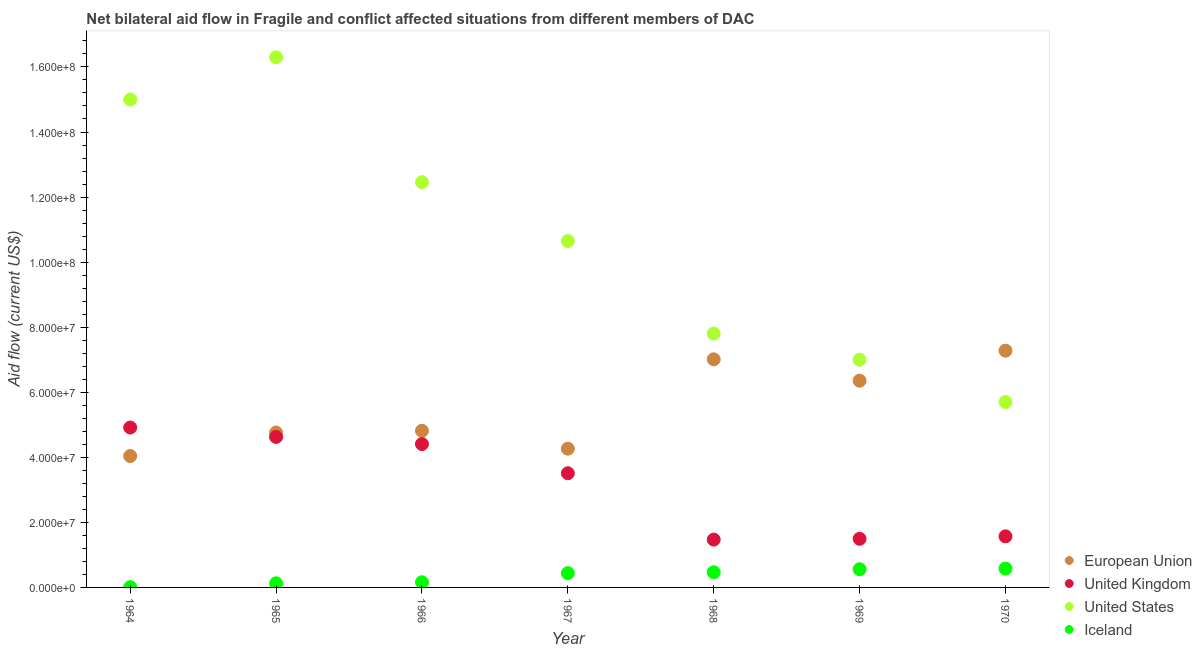How many different coloured dotlines are there?
Your answer should be compact. 4. What is the amount of aid given by us in 1969?
Ensure brevity in your answer.  7.00e+07. Across all years, what is the maximum amount of aid given by iceland?
Offer a very short reply. 5.80e+06. Across all years, what is the minimum amount of aid given by eu?
Offer a very short reply. 4.04e+07. In which year was the amount of aid given by eu maximum?
Ensure brevity in your answer.  1970. In which year was the amount of aid given by eu minimum?
Your response must be concise. 1964. What is the total amount of aid given by us in the graph?
Provide a succinct answer. 7.49e+08. What is the difference between the amount of aid given by uk in 1966 and that in 1967?
Your response must be concise. 8.98e+06. What is the difference between the amount of aid given by iceland in 1965 and the amount of aid given by us in 1964?
Offer a terse response. -1.49e+08. What is the average amount of aid given by us per year?
Give a very brief answer. 1.07e+08. In the year 1967, what is the difference between the amount of aid given by iceland and amount of aid given by us?
Ensure brevity in your answer.  -1.02e+08. In how many years, is the amount of aid given by us greater than 156000000 US$?
Your answer should be compact. 1. What is the ratio of the amount of aid given by eu in 1964 to that in 1967?
Your response must be concise. 0.95. What is the difference between the highest and the second highest amount of aid given by us?
Ensure brevity in your answer.  1.30e+07. What is the difference between the highest and the lowest amount of aid given by uk?
Your answer should be compact. 3.44e+07. In how many years, is the amount of aid given by iceland greater than the average amount of aid given by iceland taken over all years?
Make the answer very short. 4. Is it the case that in every year, the sum of the amount of aid given by iceland and amount of aid given by us is greater than the sum of amount of aid given by eu and amount of aid given by uk?
Your answer should be very brief. Yes. Does the amount of aid given by eu monotonically increase over the years?
Offer a terse response. No. Is the amount of aid given by eu strictly less than the amount of aid given by us over the years?
Give a very brief answer. No. How many years are there in the graph?
Ensure brevity in your answer.  7. What is the difference between two consecutive major ticks on the Y-axis?
Your answer should be compact. 2.00e+07. Does the graph contain any zero values?
Make the answer very short. No. Does the graph contain grids?
Give a very brief answer. No. How are the legend labels stacked?
Make the answer very short. Vertical. What is the title of the graph?
Ensure brevity in your answer.  Net bilateral aid flow in Fragile and conflict affected situations from different members of DAC. Does "Tracking ability" appear as one of the legend labels in the graph?
Keep it short and to the point. No. What is the label or title of the X-axis?
Ensure brevity in your answer.  Year. What is the label or title of the Y-axis?
Your answer should be compact. Aid flow (current US$). What is the Aid flow (current US$) of European Union in 1964?
Ensure brevity in your answer.  4.04e+07. What is the Aid flow (current US$) of United Kingdom in 1964?
Give a very brief answer. 4.92e+07. What is the Aid flow (current US$) in United States in 1964?
Your answer should be compact. 1.50e+08. What is the Aid flow (current US$) in Iceland in 1964?
Your response must be concise. 8.00e+04. What is the Aid flow (current US$) of European Union in 1965?
Provide a short and direct response. 4.76e+07. What is the Aid flow (current US$) in United Kingdom in 1965?
Offer a very short reply. 4.63e+07. What is the Aid flow (current US$) in United States in 1965?
Your answer should be compact. 1.63e+08. What is the Aid flow (current US$) of Iceland in 1965?
Provide a short and direct response. 1.25e+06. What is the Aid flow (current US$) of European Union in 1966?
Your answer should be compact. 4.82e+07. What is the Aid flow (current US$) of United Kingdom in 1966?
Your answer should be very brief. 4.41e+07. What is the Aid flow (current US$) in United States in 1966?
Provide a succinct answer. 1.25e+08. What is the Aid flow (current US$) in Iceland in 1966?
Your answer should be compact. 1.59e+06. What is the Aid flow (current US$) in European Union in 1967?
Your answer should be compact. 4.26e+07. What is the Aid flow (current US$) of United Kingdom in 1967?
Give a very brief answer. 3.51e+07. What is the Aid flow (current US$) in United States in 1967?
Provide a succinct answer. 1.06e+08. What is the Aid flow (current US$) of Iceland in 1967?
Provide a short and direct response. 4.39e+06. What is the Aid flow (current US$) in European Union in 1968?
Offer a terse response. 7.01e+07. What is the Aid flow (current US$) of United Kingdom in 1968?
Provide a succinct answer. 1.47e+07. What is the Aid flow (current US$) of United States in 1968?
Your answer should be very brief. 7.80e+07. What is the Aid flow (current US$) of Iceland in 1968?
Your answer should be very brief. 4.66e+06. What is the Aid flow (current US$) of European Union in 1969?
Provide a short and direct response. 6.36e+07. What is the Aid flow (current US$) in United Kingdom in 1969?
Give a very brief answer. 1.50e+07. What is the Aid flow (current US$) of United States in 1969?
Provide a succinct answer. 7.00e+07. What is the Aid flow (current US$) of Iceland in 1969?
Provide a short and direct response. 5.59e+06. What is the Aid flow (current US$) of European Union in 1970?
Ensure brevity in your answer.  7.28e+07. What is the Aid flow (current US$) in United Kingdom in 1970?
Your answer should be compact. 1.57e+07. What is the Aid flow (current US$) in United States in 1970?
Your answer should be compact. 5.70e+07. What is the Aid flow (current US$) in Iceland in 1970?
Your response must be concise. 5.80e+06. Across all years, what is the maximum Aid flow (current US$) of European Union?
Offer a terse response. 7.28e+07. Across all years, what is the maximum Aid flow (current US$) of United Kingdom?
Provide a short and direct response. 4.92e+07. Across all years, what is the maximum Aid flow (current US$) of United States?
Make the answer very short. 1.63e+08. Across all years, what is the maximum Aid flow (current US$) in Iceland?
Your answer should be very brief. 5.80e+06. Across all years, what is the minimum Aid flow (current US$) in European Union?
Keep it short and to the point. 4.04e+07. Across all years, what is the minimum Aid flow (current US$) in United Kingdom?
Make the answer very short. 1.47e+07. Across all years, what is the minimum Aid flow (current US$) of United States?
Offer a very short reply. 5.70e+07. What is the total Aid flow (current US$) in European Union in the graph?
Offer a terse response. 3.85e+08. What is the total Aid flow (current US$) of United Kingdom in the graph?
Make the answer very short. 2.20e+08. What is the total Aid flow (current US$) of United States in the graph?
Your response must be concise. 7.49e+08. What is the total Aid flow (current US$) in Iceland in the graph?
Provide a short and direct response. 2.34e+07. What is the difference between the Aid flow (current US$) in European Union in 1964 and that in 1965?
Provide a short and direct response. -7.22e+06. What is the difference between the Aid flow (current US$) in United Kingdom in 1964 and that in 1965?
Provide a succinct answer. 2.89e+06. What is the difference between the Aid flow (current US$) of United States in 1964 and that in 1965?
Give a very brief answer. -1.30e+07. What is the difference between the Aid flow (current US$) of Iceland in 1964 and that in 1965?
Provide a short and direct response. -1.17e+06. What is the difference between the Aid flow (current US$) of European Union in 1964 and that in 1966?
Your answer should be compact. -7.77e+06. What is the difference between the Aid flow (current US$) of United Kingdom in 1964 and that in 1966?
Keep it short and to the point. 5.07e+06. What is the difference between the Aid flow (current US$) of United States in 1964 and that in 1966?
Ensure brevity in your answer.  2.54e+07. What is the difference between the Aid flow (current US$) in Iceland in 1964 and that in 1966?
Offer a very short reply. -1.51e+06. What is the difference between the Aid flow (current US$) in European Union in 1964 and that in 1967?
Provide a succinct answer. -2.26e+06. What is the difference between the Aid flow (current US$) of United Kingdom in 1964 and that in 1967?
Offer a terse response. 1.40e+07. What is the difference between the Aid flow (current US$) of United States in 1964 and that in 1967?
Ensure brevity in your answer.  4.35e+07. What is the difference between the Aid flow (current US$) of Iceland in 1964 and that in 1967?
Provide a short and direct response. -4.31e+06. What is the difference between the Aid flow (current US$) in European Union in 1964 and that in 1968?
Provide a succinct answer. -2.97e+07. What is the difference between the Aid flow (current US$) in United Kingdom in 1964 and that in 1968?
Give a very brief answer. 3.44e+07. What is the difference between the Aid flow (current US$) in United States in 1964 and that in 1968?
Provide a short and direct response. 7.20e+07. What is the difference between the Aid flow (current US$) of Iceland in 1964 and that in 1968?
Provide a succinct answer. -4.58e+06. What is the difference between the Aid flow (current US$) of European Union in 1964 and that in 1969?
Give a very brief answer. -2.32e+07. What is the difference between the Aid flow (current US$) in United Kingdom in 1964 and that in 1969?
Provide a succinct answer. 3.42e+07. What is the difference between the Aid flow (current US$) of United States in 1964 and that in 1969?
Offer a very short reply. 8.00e+07. What is the difference between the Aid flow (current US$) of Iceland in 1964 and that in 1969?
Your answer should be very brief. -5.51e+06. What is the difference between the Aid flow (current US$) in European Union in 1964 and that in 1970?
Keep it short and to the point. -3.24e+07. What is the difference between the Aid flow (current US$) in United Kingdom in 1964 and that in 1970?
Ensure brevity in your answer.  3.34e+07. What is the difference between the Aid flow (current US$) in United States in 1964 and that in 1970?
Provide a short and direct response. 9.30e+07. What is the difference between the Aid flow (current US$) in Iceland in 1964 and that in 1970?
Offer a very short reply. -5.72e+06. What is the difference between the Aid flow (current US$) in European Union in 1965 and that in 1966?
Your response must be concise. -5.50e+05. What is the difference between the Aid flow (current US$) of United Kingdom in 1965 and that in 1966?
Offer a terse response. 2.18e+06. What is the difference between the Aid flow (current US$) in United States in 1965 and that in 1966?
Your response must be concise. 3.84e+07. What is the difference between the Aid flow (current US$) of European Union in 1965 and that in 1967?
Offer a very short reply. 4.96e+06. What is the difference between the Aid flow (current US$) in United Kingdom in 1965 and that in 1967?
Make the answer very short. 1.12e+07. What is the difference between the Aid flow (current US$) of United States in 1965 and that in 1967?
Provide a short and direct response. 5.65e+07. What is the difference between the Aid flow (current US$) of Iceland in 1965 and that in 1967?
Provide a succinct answer. -3.14e+06. What is the difference between the Aid flow (current US$) in European Union in 1965 and that in 1968?
Your response must be concise. -2.25e+07. What is the difference between the Aid flow (current US$) of United Kingdom in 1965 and that in 1968?
Give a very brief answer. 3.16e+07. What is the difference between the Aid flow (current US$) of United States in 1965 and that in 1968?
Ensure brevity in your answer.  8.49e+07. What is the difference between the Aid flow (current US$) of Iceland in 1965 and that in 1968?
Your answer should be very brief. -3.41e+06. What is the difference between the Aid flow (current US$) of European Union in 1965 and that in 1969?
Keep it short and to the point. -1.59e+07. What is the difference between the Aid flow (current US$) of United Kingdom in 1965 and that in 1969?
Your answer should be compact. 3.13e+07. What is the difference between the Aid flow (current US$) of United States in 1965 and that in 1969?
Provide a short and direct response. 9.30e+07. What is the difference between the Aid flow (current US$) of Iceland in 1965 and that in 1969?
Provide a short and direct response. -4.34e+06. What is the difference between the Aid flow (current US$) in European Union in 1965 and that in 1970?
Provide a short and direct response. -2.52e+07. What is the difference between the Aid flow (current US$) in United Kingdom in 1965 and that in 1970?
Your answer should be very brief. 3.06e+07. What is the difference between the Aid flow (current US$) of United States in 1965 and that in 1970?
Give a very brief answer. 1.06e+08. What is the difference between the Aid flow (current US$) of Iceland in 1965 and that in 1970?
Keep it short and to the point. -4.55e+06. What is the difference between the Aid flow (current US$) in European Union in 1966 and that in 1967?
Give a very brief answer. 5.51e+06. What is the difference between the Aid flow (current US$) in United Kingdom in 1966 and that in 1967?
Ensure brevity in your answer.  8.98e+06. What is the difference between the Aid flow (current US$) in United States in 1966 and that in 1967?
Your answer should be very brief. 1.81e+07. What is the difference between the Aid flow (current US$) of Iceland in 1966 and that in 1967?
Offer a terse response. -2.80e+06. What is the difference between the Aid flow (current US$) in European Union in 1966 and that in 1968?
Ensure brevity in your answer.  -2.20e+07. What is the difference between the Aid flow (current US$) in United Kingdom in 1966 and that in 1968?
Keep it short and to the point. 2.94e+07. What is the difference between the Aid flow (current US$) in United States in 1966 and that in 1968?
Keep it short and to the point. 4.65e+07. What is the difference between the Aid flow (current US$) of Iceland in 1966 and that in 1968?
Offer a very short reply. -3.07e+06. What is the difference between the Aid flow (current US$) of European Union in 1966 and that in 1969?
Offer a terse response. -1.54e+07. What is the difference between the Aid flow (current US$) of United Kingdom in 1966 and that in 1969?
Provide a short and direct response. 2.91e+07. What is the difference between the Aid flow (current US$) in United States in 1966 and that in 1969?
Make the answer very short. 5.46e+07. What is the difference between the Aid flow (current US$) in Iceland in 1966 and that in 1969?
Provide a succinct answer. -4.00e+06. What is the difference between the Aid flow (current US$) of European Union in 1966 and that in 1970?
Provide a succinct answer. -2.46e+07. What is the difference between the Aid flow (current US$) of United Kingdom in 1966 and that in 1970?
Keep it short and to the point. 2.84e+07. What is the difference between the Aid flow (current US$) of United States in 1966 and that in 1970?
Provide a short and direct response. 6.76e+07. What is the difference between the Aid flow (current US$) in Iceland in 1966 and that in 1970?
Your answer should be compact. -4.21e+06. What is the difference between the Aid flow (current US$) in European Union in 1967 and that in 1968?
Your response must be concise. -2.75e+07. What is the difference between the Aid flow (current US$) in United Kingdom in 1967 and that in 1968?
Your answer should be very brief. 2.04e+07. What is the difference between the Aid flow (current US$) of United States in 1967 and that in 1968?
Offer a terse response. 2.84e+07. What is the difference between the Aid flow (current US$) in European Union in 1967 and that in 1969?
Your answer should be very brief. -2.09e+07. What is the difference between the Aid flow (current US$) in United Kingdom in 1967 and that in 1969?
Offer a very short reply. 2.02e+07. What is the difference between the Aid flow (current US$) of United States in 1967 and that in 1969?
Ensure brevity in your answer.  3.65e+07. What is the difference between the Aid flow (current US$) of Iceland in 1967 and that in 1969?
Make the answer very short. -1.20e+06. What is the difference between the Aid flow (current US$) in European Union in 1967 and that in 1970?
Make the answer very short. -3.01e+07. What is the difference between the Aid flow (current US$) in United Kingdom in 1967 and that in 1970?
Give a very brief answer. 1.94e+07. What is the difference between the Aid flow (current US$) of United States in 1967 and that in 1970?
Provide a succinct answer. 4.95e+07. What is the difference between the Aid flow (current US$) in Iceland in 1967 and that in 1970?
Your answer should be compact. -1.41e+06. What is the difference between the Aid flow (current US$) of European Union in 1968 and that in 1969?
Your answer should be compact. 6.57e+06. What is the difference between the Aid flow (current US$) in United States in 1968 and that in 1969?
Make the answer very short. 8.04e+06. What is the difference between the Aid flow (current US$) in Iceland in 1968 and that in 1969?
Offer a terse response. -9.30e+05. What is the difference between the Aid flow (current US$) in European Union in 1968 and that in 1970?
Provide a short and direct response. -2.66e+06. What is the difference between the Aid flow (current US$) of United Kingdom in 1968 and that in 1970?
Offer a very short reply. -1.01e+06. What is the difference between the Aid flow (current US$) of United States in 1968 and that in 1970?
Your answer should be very brief. 2.10e+07. What is the difference between the Aid flow (current US$) of Iceland in 1968 and that in 1970?
Ensure brevity in your answer.  -1.14e+06. What is the difference between the Aid flow (current US$) of European Union in 1969 and that in 1970?
Ensure brevity in your answer.  -9.23e+06. What is the difference between the Aid flow (current US$) of United Kingdom in 1969 and that in 1970?
Make the answer very short. -7.60e+05. What is the difference between the Aid flow (current US$) of United States in 1969 and that in 1970?
Your answer should be very brief. 1.30e+07. What is the difference between the Aid flow (current US$) in European Union in 1964 and the Aid flow (current US$) in United Kingdom in 1965?
Your response must be concise. -5.87e+06. What is the difference between the Aid flow (current US$) of European Union in 1964 and the Aid flow (current US$) of United States in 1965?
Your response must be concise. -1.23e+08. What is the difference between the Aid flow (current US$) in European Union in 1964 and the Aid flow (current US$) in Iceland in 1965?
Keep it short and to the point. 3.91e+07. What is the difference between the Aid flow (current US$) in United Kingdom in 1964 and the Aid flow (current US$) in United States in 1965?
Offer a very short reply. -1.14e+08. What is the difference between the Aid flow (current US$) of United Kingdom in 1964 and the Aid flow (current US$) of Iceland in 1965?
Make the answer very short. 4.79e+07. What is the difference between the Aid flow (current US$) of United States in 1964 and the Aid flow (current US$) of Iceland in 1965?
Your answer should be very brief. 1.49e+08. What is the difference between the Aid flow (current US$) in European Union in 1964 and the Aid flow (current US$) in United Kingdom in 1966?
Give a very brief answer. -3.69e+06. What is the difference between the Aid flow (current US$) in European Union in 1964 and the Aid flow (current US$) in United States in 1966?
Keep it short and to the point. -8.42e+07. What is the difference between the Aid flow (current US$) in European Union in 1964 and the Aid flow (current US$) in Iceland in 1966?
Keep it short and to the point. 3.88e+07. What is the difference between the Aid flow (current US$) in United Kingdom in 1964 and the Aid flow (current US$) in United States in 1966?
Ensure brevity in your answer.  -7.54e+07. What is the difference between the Aid flow (current US$) in United Kingdom in 1964 and the Aid flow (current US$) in Iceland in 1966?
Offer a terse response. 4.76e+07. What is the difference between the Aid flow (current US$) of United States in 1964 and the Aid flow (current US$) of Iceland in 1966?
Provide a short and direct response. 1.48e+08. What is the difference between the Aid flow (current US$) in European Union in 1964 and the Aid flow (current US$) in United Kingdom in 1967?
Provide a succinct answer. 5.29e+06. What is the difference between the Aid flow (current US$) of European Union in 1964 and the Aid flow (current US$) of United States in 1967?
Your answer should be very brief. -6.61e+07. What is the difference between the Aid flow (current US$) of European Union in 1964 and the Aid flow (current US$) of Iceland in 1967?
Keep it short and to the point. 3.60e+07. What is the difference between the Aid flow (current US$) in United Kingdom in 1964 and the Aid flow (current US$) in United States in 1967?
Give a very brief answer. -5.73e+07. What is the difference between the Aid flow (current US$) in United Kingdom in 1964 and the Aid flow (current US$) in Iceland in 1967?
Provide a succinct answer. 4.48e+07. What is the difference between the Aid flow (current US$) of United States in 1964 and the Aid flow (current US$) of Iceland in 1967?
Ensure brevity in your answer.  1.46e+08. What is the difference between the Aid flow (current US$) in European Union in 1964 and the Aid flow (current US$) in United Kingdom in 1968?
Provide a short and direct response. 2.57e+07. What is the difference between the Aid flow (current US$) of European Union in 1964 and the Aid flow (current US$) of United States in 1968?
Keep it short and to the point. -3.76e+07. What is the difference between the Aid flow (current US$) of European Union in 1964 and the Aid flow (current US$) of Iceland in 1968?
Offer a very short reply. 3.57e+07. What is the difference between the Aid flow (current US$) in United Kingdom in 1964 and the Aid flow (current US$) in United States in 1968?
Your response must be concise. -2.89e+07. What is the difference between the Aid flow (current US$) of United Kingdom in 1964 and the Aid flow (current US$) of Iceland in 1968?
Provide a short and direct response. 4.45e+07. What is the difference between the Aid flow (current US$) in United States in 1964 and the Aid flow (current US$) in Iceland in 1968?
Keep it short and to the point. 1.45e+08. What is the difference between the Aid flow (current US$) in European Union in 1964 and the Aid flow (current US$) in United Kingdom in 1969?
Your response must be concise. 2.54e+07. What is the difference between the Aid flow (current US$) of European Union in 1964 and the Aid flow (current US$) of United States in 1969?
Your response must be concise. -2.96e+07. What is the difference between the Aid flow (current US$) of European Union in 1964 and the Aid flow (current US$) of Iceland in 1969?
Your answer should be very brief. 3.48e+07. What is the difference between the Aid flow (current US$) in United Kingdom in 1964 and the Aid flow (current US$) in United States in 1969?
Offer a terse response. -2.08e+07. What is the difference between the Aid flow (current US$) of United Kingdom in 1964 and the Aid flow (current US$) of Iceland in 1969?
Your response must be concise. 4.36e+07. What is the difference between the Aid flow (current US$) in United States in 1964 and the Aid flow (current US$) in Iceland in 1969?
Provide a short and direct response. 1.44e+08. What is the difference between the Aid flow (current US$) in European Union in 1964 and the Aid flow (current US$) in United Kingdom in 1970?
Make the answer very short. 2.47e+07. What is the difference between the Aid flow (current US$) in European Union in 1964 and the Aid flow (current US$) in United States in 1970?
Your answer should be very brief. -1.66e+07. What is the difference between the Aid flow (current US$) in European Union in 1964 and the Aid flow (current US$) in Iceland in 1970?
Your answer should be very brief. 3.46e+07. What is the difference between the Aid flow (current US$) of United Kingdom in 1964 and the Aid flow (current US$) of United States in 1970?
Provide a short and direct response. -7.85e+06. What is the difference between the Aid flow (current US$) in United Kingdom in 1964 and the Aid flow (current US$) in Iceland in 1970?
Ensure brevity in your answer.  4.34e+07. What is the difference between the Aid flow (current US$) in United States in 1964 and the Aid flow (current US$) in Iceland in 1970?
Your answer should be compact. 1.44e+08. What is the difference between the Aid flow (current US$) of European Union in 1965 and the Aid flow (current US$) of United Kingdom in 1966?
Your response must be concise. 3.53e+06. What is the difference between the Aid flow (current US$) of European Union in 1965 and the Aid flow (current US$) of United States in 1966?
Offer a very short reply. -7.70e+07. What is the difference between the Aid flow (current US$) in European Union in 1965 and the Aid flow (current US$) in Iceland in 1966?
Offer a terse response. 4.60e+07. What is the difference between the Aid flow (current US$) in United Kingdom in 1965 and the Aid flow (current US$) in United States in 1966?
Offer a very short reply. -7.83e+07. What is the difference between the Aid flow (current US$) in United Kingdom in 1965 and the Aid flow (current US$) in Iceland in 1966?
Provide a succinct answer. 4.47e+07. What is the difference between the Aid flow (current US$) of United States in 1965 and the Aid flow (current US$) of Iceland in 1966?
Keep it short and to the point. 1.61e+08. What is the difference between the Aid flow (current US$) in European Union in 1965 and the Aid flow (current US$) in United Kingdom in 1967?
Give a very brief answer. 1.25e+07. What is the difference between the Aid flow (current US$) of European Union in 1965 and the Aid flow (current US$) of United States in 1967?
Provide a succinct answer. -5.89e+07. What is the difference between the Aid flow (current US$) of European Union in 1965 and the Aid flow (current US$) of Iceland in 1967?
Provide a succinct answer. 4.32e+07. What is the difference between the Aid flow (current US$) in United Kingdom in 1965 and the Aid flow (current US$) in United States in 1967?
Your answer should be very brief. -6.02e+07. What is the difference between the Aid flow (current US$) of United Kingdom in 1965 and the Aid flow (current US$) of Iceland in 1967?
Ensure brevity in your answer.  4.19e+07. What is the difference between the Aid flow (current US$) in United States in 1965 and the Aid flow (current US$) in Iceland in 1967?
Your answer should be very brief. 1.59e+08. What is the difference between the Aid flow (current US$) in European Union in 1965 and the Aid flow (current US$) in United Kingdom in 1968?
Provide a succinct answer. 3.29e+07. What is the difference between the Aid flow (current US$) in European Union in 1965 and the Aid flow (current US$) in United States in 1968?
Offer a terse response. -3.04e+07. What is the difference between the Aid flow (current US$) in European Union in 1965 and the Aid flow (current US$) in Iceland in 1968?
Ensure brevity in your answer.  4.30e+07. What is the difference between the Aid flow (current US$) in United Kingdom in 1965 and the Aid flow (current US$) in United States in 1968?
Make the answer very short. -3.18e+07. What is the difference between the Aid flow (current US$) of United Kingdom in 1965 and the Aid flow (current US$) of Iceland in 1968?
Your answer should be compact. 4.16e+07. What is the difference between the Aid flow (current US$) of United States in 1965 and the Aid flow (current US$) of Iceland in 1968?
Give a very brief answer. 1.58e+08. What is the difference between the Aid flow (current US$) of European Union in 1965 and the Aid flow (current US$) of United Kingdom in 1969?
Your answer should be compact. 3.27e+07. What is the difference between the Aid flow (current US$) of European Union in 1965 and the Aid flow (current US$) of United States in 1969?
Your answer should be compact. -2.24e+07. What is the difference between the Aid flow (current US$) in European Union in 1965 and the Aid flow (current US$) in Iceland in 1969?
Your answer should be compact. 4.20e+07. What is the difference between the Aid flow (current US$) in United Kingdom in 1965 and the Aid flow (current US$) in United States in 1969?
Keep it short and to the point. -2.37e+07. What is the difference between the Aid flow (current US$) in United Kingdom in 1965 and the Aid flow (current US$) in Iceland in 1969?
Your answer should be compact. 4.07e+07. What is the difference between the Aid flow (current US$) in United States in 1965 and the Aid flow (current US$) in Iceland in 1969?
Your answer should be compact. 1.57e+08. What is the difference between the Aid flow (current US$) of European Union in 1965 and the Aid flow (current US$) of United Kingdom in 1970?
Make the answer very short. 3.19e+07. What is the difference between the Aid flow (current US$) in European Union in 1965 and the Aid flow (current US$) in United States in 1970?
Keep it short and to the point. -9.39e+06. What is the difference between the Aid flow (current US$) of European Union in 1965 and the Aid flow (current US$) of Iceland in 1970?
Offer a very short reply. 4.18e+07. What is the difference between the Aid flow (current US$) in United Kingdom in 1965 and the Aid flow (current US$) in United States in 1970?
Your response must be concise. -1.07e+07. What is the difference between the Aid flow (current US$) in United Kingdom in 1965 and the Aid flow (current US$) in Iceland in 1970?
Make the answer very short. 4.05e+07. What is the difference between the Aid flow (current US$) in United States in 1965 and the Aid flow (current US$) in Iceland in 1970?
Keep it short and to the point. 1.57e+08. What is the difference between the Aid flow (current US$) in European Union in 1966 and the Aid flow (current US$) in United Kingdom in 1967?
Provide a short and direct response. 1.31e+07. What is the difference between the Aid flow (current US$) in European Union in 1966 and the Aid flow (current US$) in United States in 1967?
Offer a very short reply. -5.83e+07. What is the difference between the Aid flow (current US$) of European Union in 1966 and the Aid flow (current US$) of Iceland in 1967?
Your answer should be compact. 4.38e+07. What is the difference between the Aid flow (current US$) of United Kingdom in 1966 and the Aid flow (current US$) of United States in 1967?
Offer a very short reply. -6.24e+07. What is the difference between the Aid flow (current US$) of United Kingdom in 1966 and the Aid flow (current US$) of Iceland in 1967?
Ensure brevity in your answer.  3.97e+07. What is the difference between the Aid flow (current US$) of United States in 1966 and the Aid flow (current US$) of Iceland in 1967?
Your response must be concise. 1.20e+08. What is the difference between the Aid flow (current US$) of European Union in 1966 and the Aid flow (current US$) of United Kingdom in 1968?
Your response must be concise. 3.35e+07. What is the difference between the Aid flow (current US$) in European Union in 1966 and the Aid flow (current US$) in United States in 1968?
Your answer should be compact. -2.99e+07. What is the difference between the Aid flow (current US$) of European Union in 1966 and the Aid flow (current US$) of Iceland in 1968?
Provide a short and direct response. 4.35e+07. What is the difference between the Aid flow (current US$) of United Kingdom in 1966 and the Aid flow (current US$) of United States in 1968?
Provide a succinct answer. -3.40e+07. What is the difference between the Aid flow (current US$) in United Kingdom in 1966 and the Aid flow (current US$) in Iceland in 1968?
Your answer should be compact. 3.94e+07. What is the difference between the Aid flow (current US$) of United States in 1966 and the Aid flow (current US$) of Iceland in 1968?
Provide a short and direct response. 1.20e+08. What is the difference between the Aid flow (current US$) of European Union in 1966 and the Aid flow (current US$) of United Kingdom in 1969?
Offer a terse response. 3.32e+07. What is the difference between the Aid flow (current US$) of European Union in 1966 and the Aid flow (current US$) of United States in 1969?
Provide a succinct answer. -2.18e+07. What is the difference between the Aid flow (current US$) in European Union in 1966 and the Aid flow (current US$) in Iceland in 1969?
Your response must be concise. 4.26e+07. What is the difference between the Aid flow (current US$) of United Kingdom in 1966 and the Aid flow (current US$) of United States in 1969?
Your answer should be compact. -2.59e+07. What is the difference between the Aid flow (current US$) in United Kingdom in 1966 and the Aid flow (current US$) in Iceland in 1969?
Your answer should be very brief. 3.85e+07. What is the difference between the Aid flow (current US$) of United States in 1966 and the Aid flow (current US$) of Iceland in 1969?
Give a very brief answer. 1.19e+08. What is the difference between the Aid flow (current US$) of European Union in 1966 and the Aid flow (current US$) of United Kingdom in 1970?
Give a very brief answer. 3.24e+07. What is the difference between the Aid flow (current US$) of European Union in 1966 and the Aid flow (current US$) of United States in 1970?
Provide a succinct answer. -8.84e+06. What is the difference between the Aid flow (current US$) of European Union in 1966 and the Aid flow (current US$) of Iceland in 1970?
Your response must be concise. 4.24e+07. What is the difference between the Aid flow (current US$) of United Kingdom in 1966 and the Aid flow (current US$) of United States in 1970?
Your answer should be very brief. -1.29e+07. What is the difference between the Aid flow (current US$) of United Kingdom in 1966 and the Aid flow (current US$) of Iceland in 1970?
Make the answer very short. 3.83e+07. What is the difference between the Aid flow (current US$) in United States in 1966 and the Aid flow (current US$) in Iceland in 1970?
Provide a succinct answer. 1.19e+08. What is the difference between the Aid flow (current US$) in European Union in 1967 and the Aid flow (current US$) in United Kingdom in 1968?
Give a very brief answer. 2.80e+07. What is the difference between the Aid flow (current US$) of European Union in 1967 and the Aid flow (current US$) of United States in 1968?
Your response must be concise. -3.54e+07. What is the difference between the Aid flow (current US$) in European Union in 1967 and the Aid flow (current US$) in Iceland in 1968?
Your answer should be very brief. 3.80e+07. What is the difference between the Aid flow (current US$) of United Kingdom in 1967 and the Aid flow (current US$) of United States in 1968?
Offer a very short reply. -4.29e+07. What is the difference between the Aid flow (current US$) in United Kingdom in 1967 and the Aid flow (current US$) in Iceland in 1968?
Offer a very short reply. 3.04e+07. What is the difference between the Aid flow (current US$) in United States in 1967 and the Aid flow (current US$) in Iceland in 1968?
Your response must be concise. 1.02e+08. What is the difference between the Aid flow (current US$) of European Union in 1967 and the Aid flow (current US$) of United Kingdom in 1969?
Your answer should be compact. 2.77e+07. What is the difference between the Aid flow (current US$) in European Union in 1967 and the Aid flow (current US$) in United States in 1969?
Offer a very short reply. -2.74e+07. What is the difference between the Aid flow (current US$) of European Union in 1967 and the Aid flow (current US$) of Iceland in 1969?
Ensure brevity in your answer.  3.71e+07. What is the difference between the Aid flow (current US$) of United Kingdom in 1967 and the Aid flow (current US$) of United States in 1969?
Offer a terse response. -3.49e+07. What is the difference between the Aid flow (current US$) of United Kingdom in 1967 and the Aid flow (current US$) of Iceland in 1969?
Make the answer very short. 2.95e+07. What is the difference between the Aid flow (current US$) of United States in 1967 and the Aid flow (current US$) of Iceland in 1969?
Your answer should be very brief. 1.01e+08. What is the difference between the Aid flow (current US$) of European Union in 1967 and the Aid flow (current US$) of United Kingdom in 1970?
Offer a very short reply. 2.69e+07. What is the difference between the Aid flow (current US$) in European Union in 1967 and the Aid flow (current US$) in United States in 1970?
Your answer should be very brief. -1.44e+07. What is the difference between the Aid flow (current US$) in European Union in 1967 and the Aid flow (current US$) in Iceland in 1970?
Ensure brevity in your answer.  3.68e+07. What is the difference between the Aid flow (current US$) of United Kingdom in 1967 and the Aid flow (current US$) of United States in 1970?
Your answer should be very brief. -2.19e+07. What is the difference between the Aid flow (current US$) of United Kingdom in 1967 and the Aid flow (current US$) of Iceland in 1970?
Provide a short and direct response. 2.93e+07. What is the difference between the Aid flow (current US$) in United States in 1967 and the Aid flow (current US$) in Iceland in 1970?
Give a very brief answer. 1.01e+08. What is the difference between the Aid flow (current US$) of European Union in 1968 and the Aid flow (current US$) of United Kingdom in 1969?
Offer a terse response. 5.52e+07. What is the difference between the Aid flow (current US$) in European Union in 1968 and the Aid flow (current US$) in United States in 1969?
Your answer should be compact. 1.20e+05. What is the difference between the Aid flow (current US$) of European Union in 1968 and the Aid flow (current US$) of Iceland in 1969?
Your answer should be compact. 6.45e+07. What is the difference between the Aid flow (current US$) in United Kingdom in 1968 and the Aid flow (current US$) in United States in 1969?
Give a very brief answer. -5.53e+07. What is the difference between the Aid flow (current US$) in United Kingdom in 1968 and the Aid flow (current US$) in Iceland in 1969?
Offer a terse response. 9.11e+06. What is the difference between the Aid flow (current US$) in United States in 1968 and the Aid flow (current US$) in Iceland in 1969?
Your answer should be very brief. 7.24e+07. What is the difference between the Aid flow (current US$) in European Union in 1968 and the Aid flow (current US$) in United Kingdom in 1970?
Your answer should be very brief. 5.44e+07. What is the difference between the Aid flow (current US$) in European Union in 1968 and the Aid flow (current US$) in United States in 1970?
Offer a terse response. 1.31e+07. What is the difference between the Aid flow (current US$) in European Union in 1968 and the Aid flow (current US$) in Iceland in 1970?
Give a very brief answer. 6.43e+07. What is the difference between the Aid flow (current US$) in United Kingdom in 1968 and the Aid flow (current US$) in United States in 1970?
Make the answer very short. -4.23e+07. What is the difference between the Aid flow (current US$) of United Kingdom in 1968 and the Aid flow (current US$) of Iceland in 1970?
Make the answer very short. 8.90e+06. What is the difference between the Aid flow (current US$) of United States in 1968 and the Aid flow (current US$) of Iceland in 1970?
Provide a short and direct response. 7.22e+07. What is the difference between the Aid flow (current US$) in European Union in 1969 and the Aid flow (current US$) in United Kingdom in 1970?
Make the answer very short. 4.78e+07. What is the difference between the Aid flow (current US$) of European Union in 1969 and the Aid flow (current US$) of United States in 1970?
Make the answer very short. 6.55e+06. What is the difference between the Aid flow (current US$) of European Union in 1969 and the Aid flow (current US$) of Iceland in 1970?
Offer a very short reply. 5.78e+07. What is the difference between the Aid flow (current US$) of United Kingdom in 1969 and the Aid flow (current US$) of United States in 1970?
Provide a short and direct response. -4.20e+07. What is the difference between the Aid flow (current US$) of United Kingdom in 1969 and the Aid flow (current US$) of Iceland in 1970?
Your answer should be compact. 9.15e+06. What is the difference between the Aid flow (current US$) in United States in 1969 and the Aid flow (current US$) in Iceland in 1970?
Provide a short and direct response. 6.42e+07. What is the average Aid flow (current US$) in European Union per year?
Keep it short and to the point. 5.50e+07. What is the average Aid flow (current US$) in United Kingdom per year?
Your answer should be very brief. 3.14e+07. What is the average Aid flow (current US$) in United States per year?
Keep it short and to the point. 1.07e+08. What is the average Aid flow (current US$) in Iceland per year?
Provide a succinct answer. 3.34e+06. In the year 1964, what is the difference between the Aid flow (current US$) of European Union and Aid flow (current US$) of United Kingdom?
Ensure brevity in your answer.  -8.76e+06. In the year 1964, what is the difference between the Aid flow (current US$) of European Union and Aid flow (current US$) of United States?
Ensure brevity in your answer.  -1.10e+08. In the year 1964, what is the difference between the Aid flow (current US$) of European Union and Aid flow (current US$) of Iceland?
Your response must be concise. 4.03e+07. In the year 1964, what is the difference between the Aid flow (current US$) in United Kingdom and Aid flow (current US$) in United States?
Ensure brevity in your answer.  -1.01e+08. In the year 1964, what is the difference between the Aid flow (current US$) of United Kingdom and Aid flow (current US$) of Iceland?
Make the answer very short. 4.91e+07. In the year 1964, what is the difference between the Aid flow (current US$) in United States and Aid flow (current US$) in Iceland?
Your answer should be compact. 1.50e+08. In the year 1965, what is the difference between the Aid flow (current US$) in European Union and Aid flow (current US$) in United Kingdom?
Provide a short and direct response. 1.35e+06. In the year 1965, what is the difference between the Aid flow (current US$) of European Union and Aid flow (current US$) of United States?
Offer a very short reply. -1.15e+08. In the year 1965, what is the difference between the Aid flow (current US$) of European Union and Aid flow (current US$) of Iceland?
Offer a terse response. 4.64e+07. In the year 1965, what is the difference between the Aid flow (current US$) of United Kingdom and Aid flow (current US$) of United States?
Your response must be concise. -1.17e+08. In the year 1965, what is the difference between the Aid flow (current US$) of United Kingdom and Aid flow (current US$) of Iceland?
Your answer should be compact. 4.50e+07. In the year 1965, what is the difference between the Aid flow (current US$) of United States and Aid flow (current US$) of Iceland?
Your response must be concise. 1.62e+08. In the year 1966, what is the difference between the Aid flow (current US$) in European Union and Aid flow (current US$) in United Kingdom?
Provide a short and direct response. 4.08e+06. In the year 1966, what is the difference between the Aid flow (current US$) of European Union and Aid flow (current US$) of United States?
Your answer should be very brief. -7.64e+07. In the year 1966, what is the difference between the Aid flow (current US$) of European Union and Aid flow (current US$) of Iceland?
Ensure brevity in your answer.  4.66e+07. In the year 1966, what is the difference between the Aid flow (current US$) of United Kingdom and Aid flow (current US$) of United States?
Offer a terse response. -8.05e+07. In the year 1966, what is the difference between the Aid flow (current US$) in United Kingdom and Aid flow (current US$) in Iceland?
Make the answer very short. 4.25e+07. In the year 1966, what is the difference between the Aid flow (current US$) in United States and Aid flow (current US$) in Iceland?
Offer a terse response. 1.23e+08. In the year 1967, what is the difference between the Aid flow (current US$) in European Union and Aid flow (current US$) in United Kingdom?
Your answer should be very brief. 7.55e+06. In the year 1967, what is the difference between the Aid flow (current US$) in European Union and Aid flow (current US$) in United States?
Give a very brief answer. -6.38e+07. In the year 1967, what is the difference between the Aid flow (current US$) of European Union and Aid flow (current US$) of Iceland?
Your answer should be compact. 3.83e+07. In the year 1967, what is the difference between the Aid flow (current US$) of United Kingdom and Aid flow (current US$) of United States?
Your answer should be compact. -7.14e+07. In the year 1967, what is the difference between the Aid flow (current US$) of United Kingdom and Aid flow (current US$) of Iceland?
Your answer should be compact. 3.07e+07. In the year 1967, what is the difference between the Aid flow (current US$) of United States and Aid flow (current US$) of Iceland?
Your response must be concise. 1.02e+08. In the year 1968, what is the difference between the Aid flow (current US$) in European Union and Aid flow (current US$) in United Kingdom?
Ensure brevity in your answer.  5.54e+07. In the year 1968, what is the difference between the Aid flow (current US$) in European Union and Aid flow (current US$) in United States?
Ensure brevity in your answer.  -7.92e+06. In the year 1968, what is the difference between the Aid flow (current US$) of European Union and Aid flow (current US$) of Iceland?
Provide a short and direct response. 6.55e+07. In the year 1968, what is the difference between the Aid flow (current US$) in United Kingdom and Aid flow (current US$) in United States?
Offer a very short reply. -6.33e+07. In the year 1968, what is the difference between the Aid flow (current US$) of United Kingdom and Aid flow (current US$) of Iceland?
Keep it short and to the point. 1.00e+07. In the year 1968, what is the difference between the Aid flow (current US$) of United States and Aid flow (current US$) of Iceland?
Provide a short and direct response. 7.34e+07. In the year 1969, what is the difference between the Aid flow (current US$) in European Union and Aid flow (current US$) in United Kingdom?
Ensure brevity in your answer.  4.86e+07. In the year 1969, what is the difference between the Aid flow (current US$) of European Union and Aid flow (current US$) of United States?
Keep it short and to the point. -6.45e+06. In the year 1969, what is the difference between the Aid flow (current US$) of European Union and Aid flow (current US$) of Iceland?
Your answer should be very brief. 5.80e+07. In the year 1969, what is the difference between the Aid flow (current US$) in United Kingdom and Aid flow (current US$) in United States?
Ensure brevity in your answer.  -5.50e+07. In the year 1969, what is the difference between the Aid flow (current US$) in United Kingdom and Aid flow (current US$) in Iceland?
Keep it short and to the point. 9.36e+06. In the year 1969, what is the difference between the Aid flow (current US$) in United States and Aid flow (current US$) in Iceland?
Your answer should be compact. 6.44e+07. In the year 1970, what is the difference between the Aid flow (current US$) of European Union and Aid flow (current US$) of United Kingdom?
Your answer should be very brief. 5.71e+07. In the year 1970, what is the difference between the Aid flow (current US$) of European Union and Aid flow (current US$) of United States?
Offer a terse response. 1.58e+07. In the year 1970, what is the difference between the Aid flow (current US$) of European Union and Aid flow (current US$) of Iceland?
Your answer should be compact. 6.70e+07. In the year 1970, what is the difference between the Aid flow (current US$) of United Kingdom and Aid flow (current US$) of United States?
Ensure brevity in your answer.  -4.13e+07. In the year 1970, what is the difference between the Aid flow (current US$) in United Kingdom and Aid flow (current US$) in Iceland?
Provide a succinct answer. 9.91e+06. In the year 1970, what is the difference between the Aid flow (current US$) in United States and Aid flow (current US$) in Iceland?
Your response must be concise. 5.12e+07. What is the ratio of the Aid flow (current US$) of European Union in 1964 to that in 1965?
Provide a short and direct response. 0.85. What is the ratio of the Aid flow (current US$) in United States in 1964 to that in 1965?
Offer a very short reply. 0.92. What is the ratio of the Aid flow (current US$) of Iceland in 1964 to that in 1965?
Your response must be concise. 0.06. What is the ratio of the Aid flow (current US$) in European Union in 1964 to that in 1966?
Offer a terse response. 0.84. What is the ratio of the Aid flow (current US$) in United Kingdom in 1964 to that in 1966?
Keep it short and to the point. 1.11. What is the ratio of the Aid flow (current US$) in United States in 1964 to that in 1966?
Ensure brevity in your answer.  1.2. What is the ratio of the Aid flow (current US$) in Iceland in 1964 to that in 1966?
Make the answer very short. 0.05. What is the ratio of the Aid flow (current US$) in European Union in 1964 to that in 1967?
Ensure brevity in your answer.  0.95. What is the ratio of the Aid flow (current US$) of United Kingdom in 1964 to that in 1967?
Offer a terse response. 1.4. What is the ratio of the Aid flow (current US$) of United States in 1964 to that in 1967?
Offer a very short reply. 1.41. What is the ratio of the Aid flow (current US$) of Iceland in 1964 to that in 1967?
Ensure brevity in your answer.  0.02. What is the ratio of the Aid flow (current US$) in European Union in 1964 to that in 1968?
Your response must be concise. 0.58. What is the ratio of the Aid flow (current US$) in United Kingdom in 1964 to that in 1968?
Offer a very short reply. 3.34. What is the ratio of the Aid flow (current US$) of United States in 1964 to that in 1968?
Offer a very short reply. 1.92. What is the ratio of the Aid flow (current US$) of Iceland in 1964 to that in 1968?
Give a very brief answer. 0.02. What is the ratio of the Aid flow (current US$) in European Union in 1964 to that in 1969?
Ensure brevity in your answer.  0.64. What is the ratio of the Aid flow (current US$) in United Kingdom in 1964 to that in 1969?
Your answer should be very brief. 3.29. What is the ratio of the Aid flow (current US$) in United States in 1964 to that in 1969?
Your response must be concise. 2.14. What is the ratio of the Aid flow (current US$) of Iceland in 1964 to that in 1969?
Make the answer very short. 0.01. What is the ratio of the Aid flow (current US$) in European Union in 1964 to that in 1970?
Give a very brief answer. 0.56. What is the ratio of the Aid flow (current US$) in United Kingdom in 1964 to that in 1970?
Provide a succinct answer. 3.13. What is the ratio of the Aid flow (current US$) of United States in 1964 to that in 1970?
Give a very brief answer. 2.63. What is the ratio of the Aid flow (current US$) of Iceland in 1964 to that in 1970?
Keep it short and to the point. 0.01. What is the ratio of the Aid flow (current US$) of European Union in 1965 to that in 1966?
Provide a succinct answer. 0.99. What is the ratio of the Aid flow (current US$) of United Kingdom in 1965 to that in 1966?
Provide a short and direct response. 1.05. What is the ratio of the Aid flow (current US$) of United States in 1965 to that in 1966?
Provide a succinct answer. 1.31. What is the ratio of the Aid flow (current US$) of Iceland in 1965 to that in 1966?
Your response must be concise. 0.79. What is the ratio of the Aid flow (current US$) of European Union in 1965 to that in 1967?
Make the answer very short. 1.12. What is the ratio of the Aid flow (current US$) in United Kingdom in 1965 to that in 1967?
Ensure brevity in your answer.  1.32. What is the ratio of the Aid flow (current US$) of United States in 1965 to that in 1967?
Give a very brief answer. 1.53. What is the ratio of the Aid flow (current US$) in Iceland in 1965 to that in 1967?
Provide a succinct answer. 0.28. What is the ratio of the Aid flow (current US$) in European Union in 1965 to that in 1968?
Your answer should be compact. 0.68. What is the ratio of the Aid flow (current US$) of United Kingdom in 1965 to that in 1968?
Your answer should be compact. 3.15. What is the ratio of the Aid flow (current US$) in United States in 1965 to that in 1968?
Offer a terse response. 2.09. What is the ratio of the Aid flow (current US$) in Iceland in 1965 to that in 1968?
Your answer should be very brief. 0.27. What is the ratio of the Aid flow (current US$) of European Union in 1965 to that in 1969?
Give a very brief answer. 0.75. What is the ratio of the Aid flow (current US$) of United Kingdom in 1965 to that in 1969?
Offer a terse response. 3.09. What is the ratio of the Aid flow (current US$) of United States in 1965 to that in 1969?
Ensure brevity in your answer.  2.33. What is the ratio of the Aid flow (current US$) of Iceland in 1965 to that in 1969?
Provide a short and direct response. 0.22. What is the ratio of the Aid flow (current US$) in European Union in 1965 to that in 1970?
Offer a very short reply. 0.65. What is the ratio of the Aid flow (current US$) in United Kingdom in 1965 to that in 1970?
Offer a very short reply. 2.94. What is the ratio of the Aid flow (current US$) in United States in 1965 to that in 1970?
Your response must be concise. 2.86. What is the ratio of the Aid flow (current US$) in Iceland in 1965 to that in 1970?
Ensure brevity in your answer.  0.22. What is the ratio of the Aid flow (current US$) of European Union in 1966 to that in 1967?
Your answer should be compact. 1.13. What is the ratio of the Aid flow (current US$) of United Kingdom in 1966 to that in 1967?
Offer a very short reply. 1.26. What is the ratio of the Aid flow (current US$) in United States in 1966 to that in 1967?
Your answer should be very brief. 1.17. What is the ratio of the Aid flow (current US$) of Iceland in 1966 to that in 1967?
Ensure brevity in your answer.  0.36. What is the ratio of the Aid flow (current US$) of European Union in 1966 to that in 1968?
Offer a terse response. 0.69. What is the ratio of the Aid flow (current US$) of United Kingdom in 1966 to that in 1968?
Ensure brevity in your answer.  3. What is the ratio of the Aid flow (current US$) in United States in 1966 to that in 1968?
Keep it short and to the point. 1.6. What is the ratio of the Aid flow (current US$) of Iceland in 1966 to that in 1968?
Keep it short and to the point. 0.34. What is the ratio of the Aid flow (current US$) of European Union in 1966 to that in 1969?
Offer a terse response. 0.76. What is the ratio of the Aid flow (current US$) in United Kingdom in 1966 to that in 1969?
Offer a terse response. 2.95. What is the ratio of the Aid flow (current US$) in United States in 1966 to that in 1969?
Your answer should be very brief. 1.78. What is the ratio of the Aid flow (current US$) in Iceland in 1966 to that in 1969?
Your answer should be compact. 0.28. What is the ratio of the Aid flow (current US$) of European Union in 1966 to that in 1970?
Ensure brevity in your answer.  0.66. What is the ratio of the Aid flow (current US$) of United Kingdom in 1966 to that in 1970?
Offer a terse response. 2.81. What is the ratio of the Aid flow (current US$) of United States in 1966 to that in 1970?
Keep it short and to the point. 2.19. What is the ratio of the Aid flow (current US$) in Iceland in 1966 to that in 1970?
Provide a short and direct response. 0.27. What is the ratio of the Aid flow (current US$) in European Union in 1967 to that in 1968?
Your answer should be very brief. 0.61. What is the ratio of the Aid flow (current US$) in United Kingdom in 1967 to that in 1968?
Your response must be concise. 2.39. What is the ratio of the Aid flow (current US$) in United States in 1967 to that in 1968?
Your answer should be very brief. 1.36. What is the ratio of the Aid flow (current US$) of Iceland in 1967 to that in 1968?
Make the answer very short. 0.94. What is the ratio of the Aid flow (current US$) in European Union in 1967 to that in 1969?
Provide a short and direct response. 0.67. What is the ratio of the Aid flow (current US$) of United Kingdom in 1967 to that in 1969?
Make the answer very short. 2.35. What is the ratio of the Aid flow (current US$) in United States in 1967 to that in 1969?
Offer a terse response. 1.52. What is the ratio of the Aid flow (current US$) in Iceland in 1967 to that in 1969?
Make the answer very short. 0.79. What is the ratio of the Aid flow (current US$) in European Union in 1967 to that in 1970?
Your answer should be very brief. 0.59. What is the ratio of the Aid flow (current US$) in United Kingdom in 1967 to that in 1970?
Ensure brevity in your answer.  2.23. What is the ratio of the Aid flow (current US$) of United States in 1967 to that in 1970?
Make the answer very short. 1.87. What is the ratio of the Aid flow (current US$) in Iceland in 1967 to that in 1970?
Provide a succinct answer. 0.76. What is the ratio of the Aid flow (current US$) of European Union in 1968 to that in 1969?
Your response must be concise. 1.1. What is the ratio of the Aid flow (current US$) of United Kingdom in 1968 to that in 1969?
Offer a very short reply. 0.98. What is the ratio of the Aid flow (current US$) in United States in 1968 to that in 1969?
Provide a succinct answer. 1.11. What is the ratio of the Aid flow (current US$) in Iceland in 1968 to that in 1969?
Ensure brevity in your answer.  0.83. What is the ratio of the Aid flow (current US$) in European Union in 1968 to that in 1970?
Provide a succinct answer. 0.96. What is the ratio of the Aid flow (current US$) in United Kingdom in 1968 to that in 1970?
Make the answer very short. 0.94. What is the ratio of the Aid flow (current US$) in United States in 1968 to that in 1970?
Offer a very short reply. 1.37. What is the ratio of the Aid flow (current US$) of Iceland in 1968 to that in 1970?
Your answer should be compact. 0.8. What is the ratio of the Aid flow (current US$) of European Union in 1969 to that in 1970?
Keep it short and to the point. 0.87. What is the ratio of the Aid flow (current US$) in United Kingdom in 1969 to that in 1970?
Provide a succinct answer. 0.95. What is the ratio of the Aid flow (current US$) of United States in 1969 to that in 1970?
Make the answer very short. 1.23. What is the ratio of the Aid flow (current US$) of Iceland in 1969 to that in 1970?
Offer a terse response. 0.96. What is the difference between the highest and the second highest Aid flow (current US$) of European Union?
Offer a very short reply. 2.66e+06. What is the difference between the highest and the second highest Aid flow (current US$) in United Kingdom?
Your answer should be very brief. 2.89e+06. What is the difference between the highest and the second highest Aid flow (current US$) in United States?
Keep it short and to the point. 1.30e+07. What is the difference between the highest and the second highest Aid flow (current US$) of Iceland?
Your response must be concise. 2.10e+05. What is the difference between the highest and the lowest Aid flow (current US$) in European Union?
Offer a very short reply. 3.24e+07. What is the difference between the highest and the lowest Aid flow (current US$) in United Kingdom?
Provide a succinct answer. 3.44e+07. What is the difference between the highest and the lowest Aid flow (current US$) in United States?
Your answer should be compact. 1.06e+08. What is the difference between the highest and the lowest Aid flow (current US$) in Iceland?
Your response must be concise. 5.72e+06. 